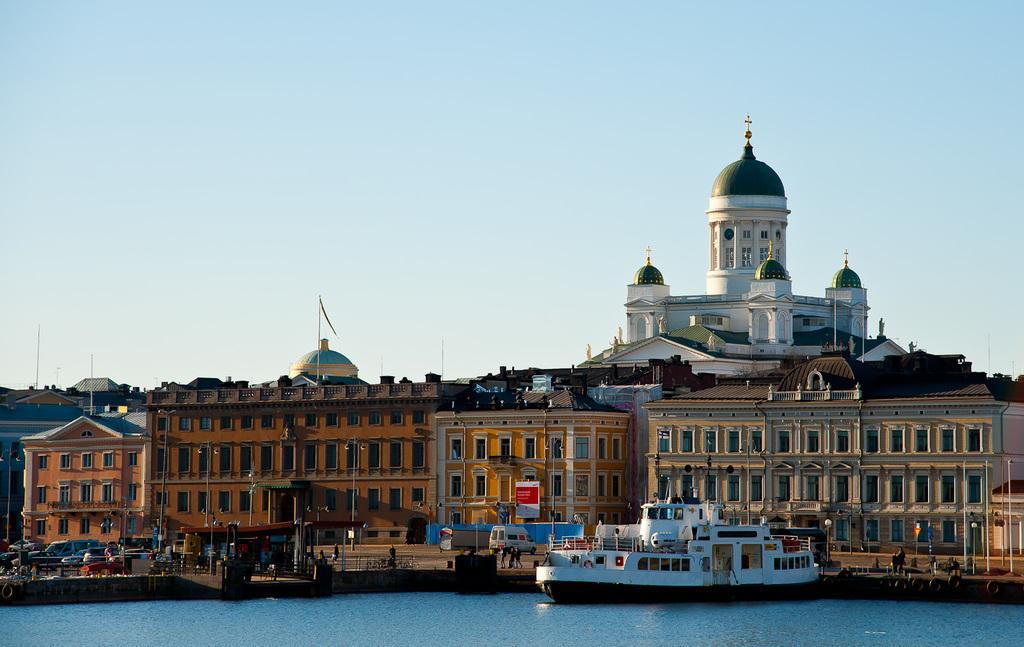Describe this image in one or two sentences. In this picture we can see a ship on water, beside the water we can see people, vehicles, electric poles with lights, name board, buildings and some objects and we can see sky in the background. 